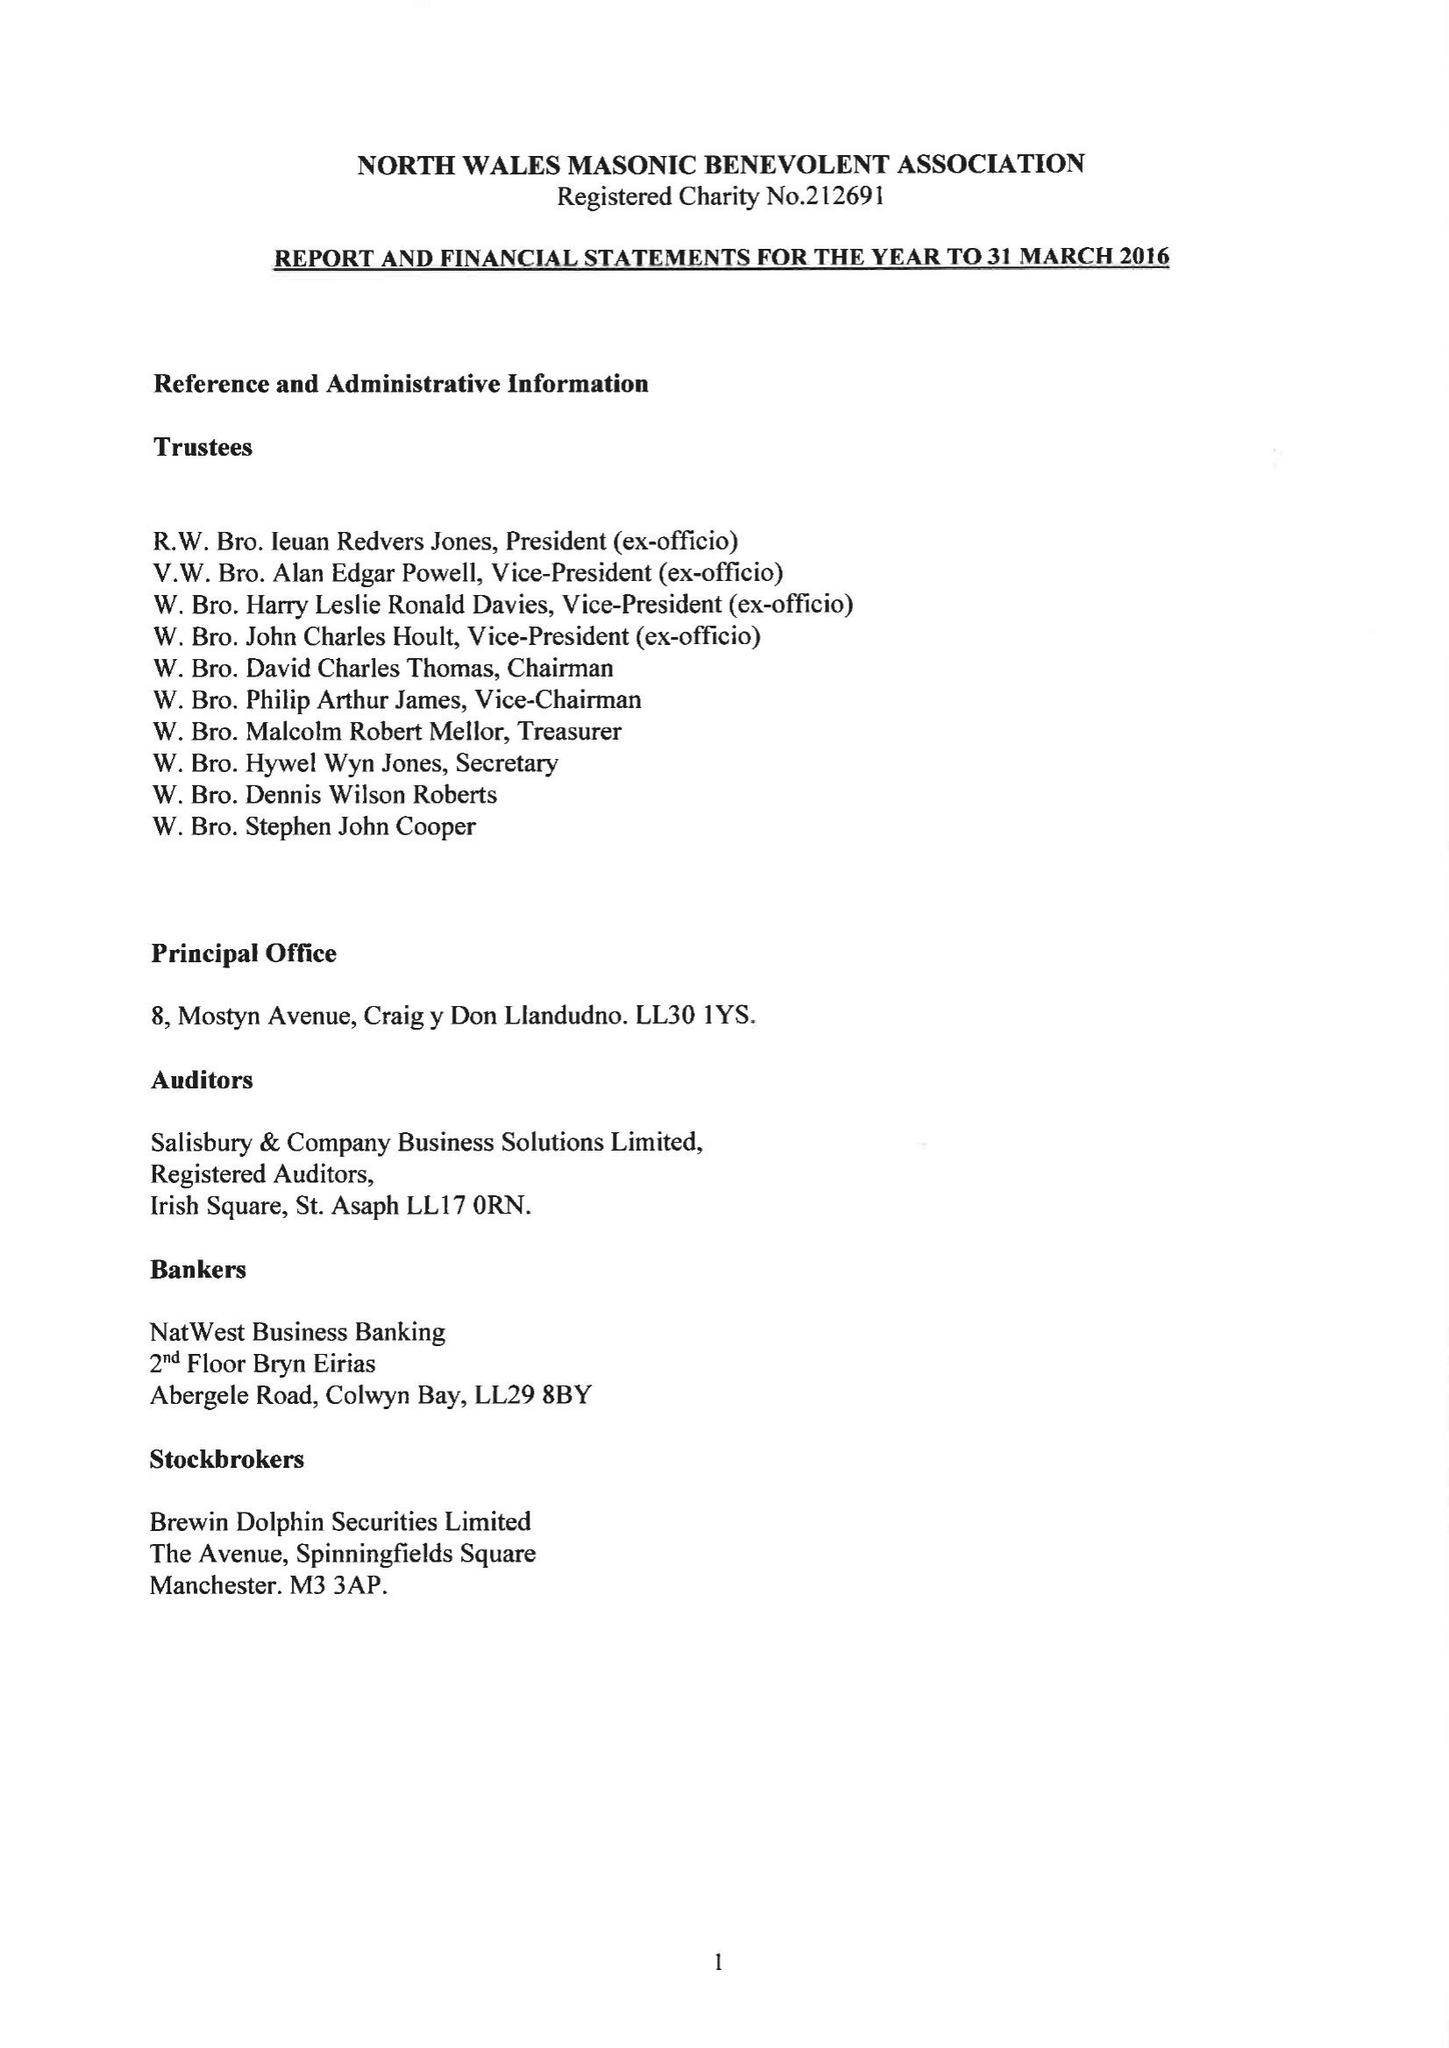What is the value for the address__postcode?
Answer the question using a single word or phrase. LL30 1YS 